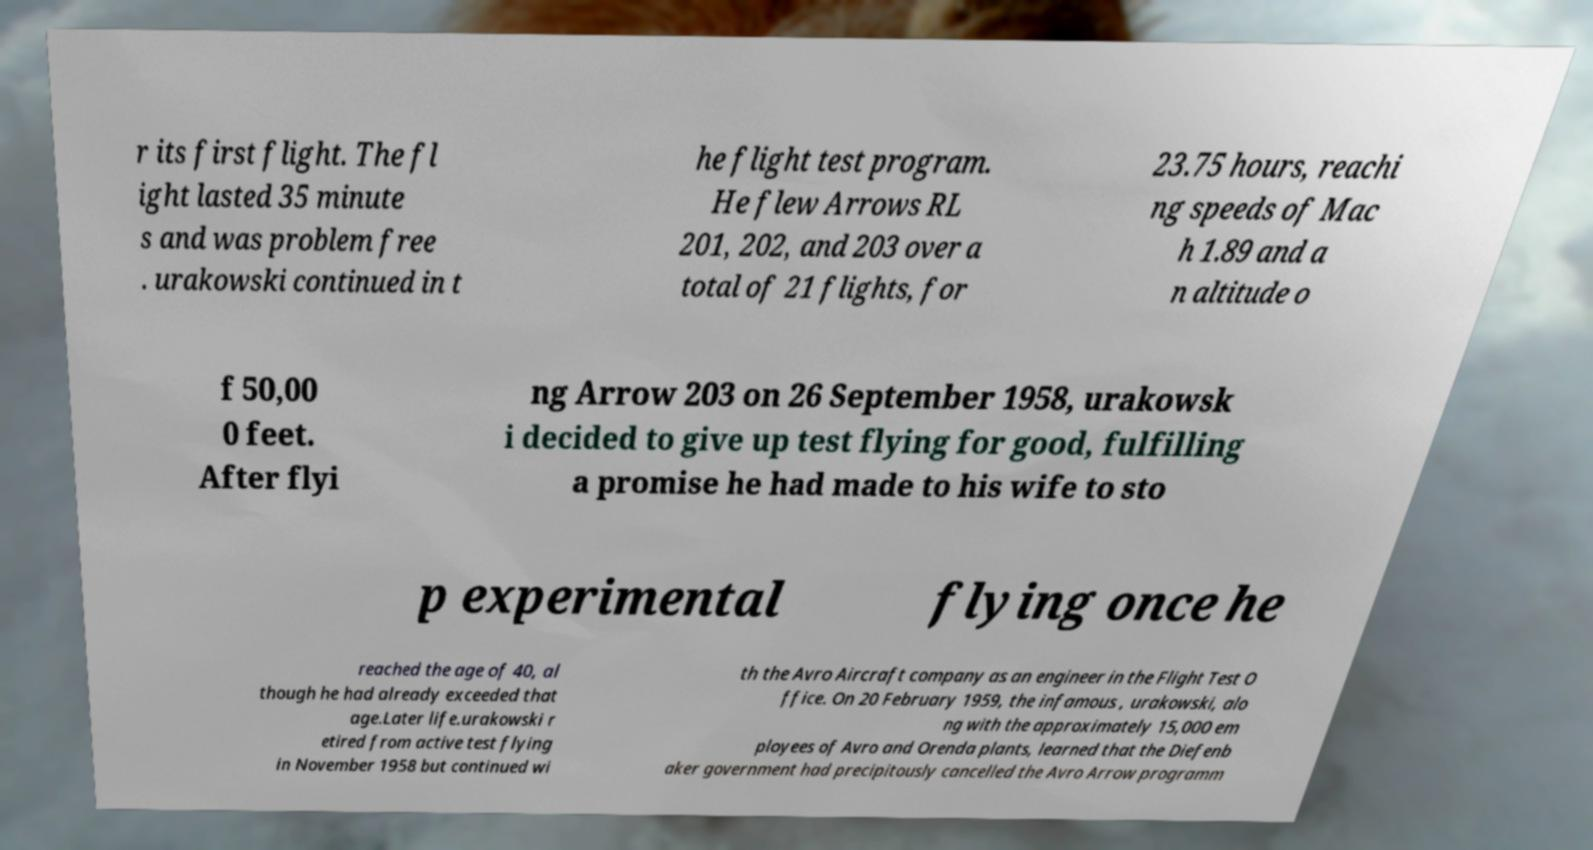Could you extract and type out the text from this image? r its first flight. The fl ight lasted 35 minute s and was problem free . urakowski continued in t he flight test program. He flew Arrows RL 201, 202, and 203 over a total of 21 flights, for 23.75 hours, reachi ng speeds of Mac h 1.89 and a n altitude o f 50,00 0 feet. After flyi ng Arrow 203 on 26 September 1958, urakowsk i decided to give up test flying for good, fulfilling a promise he had made to his wife to sto p experimental flying once he reached the age of 40, al though he had already exceeded that age.Later life.urakowski r etired from active test flying in November 1958 but continued wi th the Avro Aircraft company as an engineer in the Flight Test O ffice. On 20 February 1959, the infamous , urakowski, alo ng with the approximately 15,000 em ployees of Avro and Orenda plants, learned that the Diefenb aker government had precipitously cancelled the Avro Arrow programm 